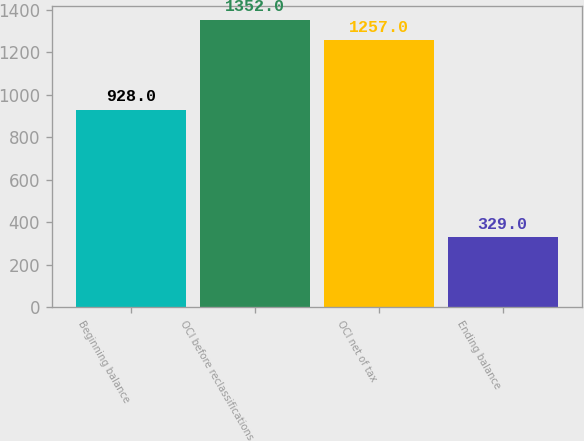<chart> <loc_0><loc_0><loc_500><loc_500><bar_chart><fcel>Beginning balance<fcel>OCI before reclassifications<fcel>OCI net of tax<fcel>Ending balance<nl><fcel>928<fcel>1352<fcel>1257<fcel>329<nl></chart> 